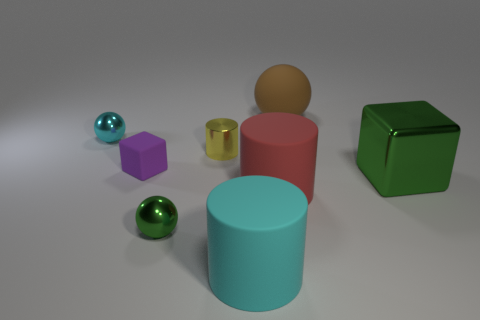What is the shape of the metallic object that is both right of the tiny rubber block and behind the large green thing?
Keep it short and to the point. Cylinder. Does the cyan metallic ball have the same size as the rubber cube?
Your answer should be compact. Yes. How many green balls are behind the large brown rubber ball?
Offer a terse response. 0. Are there an equal number of brown matte spheres that are behind the brown sphere and blocks that are on the right side of the small green metallic ball?
Provide a short and direct response. No. Does the brown thing behind the large metal cube have the same shape as the small cyan object?
Make the answer very short. Yes. Is the size of the rubber cube the same as the cyan object that is behind the yellow cylinder?
Make the answer very short. Yes. How many other objects are there of the same color as the large metallic block?
Give a very brief answer. 1. There is a small purple rubber block; are there any tiny yellow objects behind it?
Keep it short and to the point. Yes. What number of objects are either red cylinders or yellow shiny cylinders that are on the right side of the tiny cyan thing?
Give a very brief answer. 2. There is a large object that is in front of the green sphere; are there any cyan metallic things left of it?
Your response must be concise. Yes. 